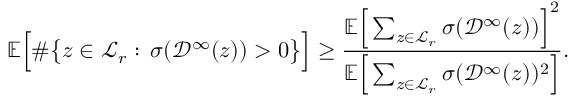Convert formula to latex. <formula><loc_0><loc_0><loc_500><loc_500>{ \mathbb { E } } \left [ \# \left \{ z \in \mathcal { L } _ { r } \colon \, \sigma ( \mathcal { D } ^ { \infty } ( z ) ) > 0 \right \} \right ] \geq \frac { { \mathbb { E } } \left [ \sum _ { z \in \mathcal { L } _ { r } } \sigma ( \mathcal { D } ^ { \infty } ( z ) ) \right ] ^ { 2 } } { { \mathbb { E } } \left [ \sum _ { z \in \mathcal { L } _ { r } } \sigma ( \mathcal { D } ^ { \infty } ( z ) ) ^ { 2 } \right ] } .</formula> 